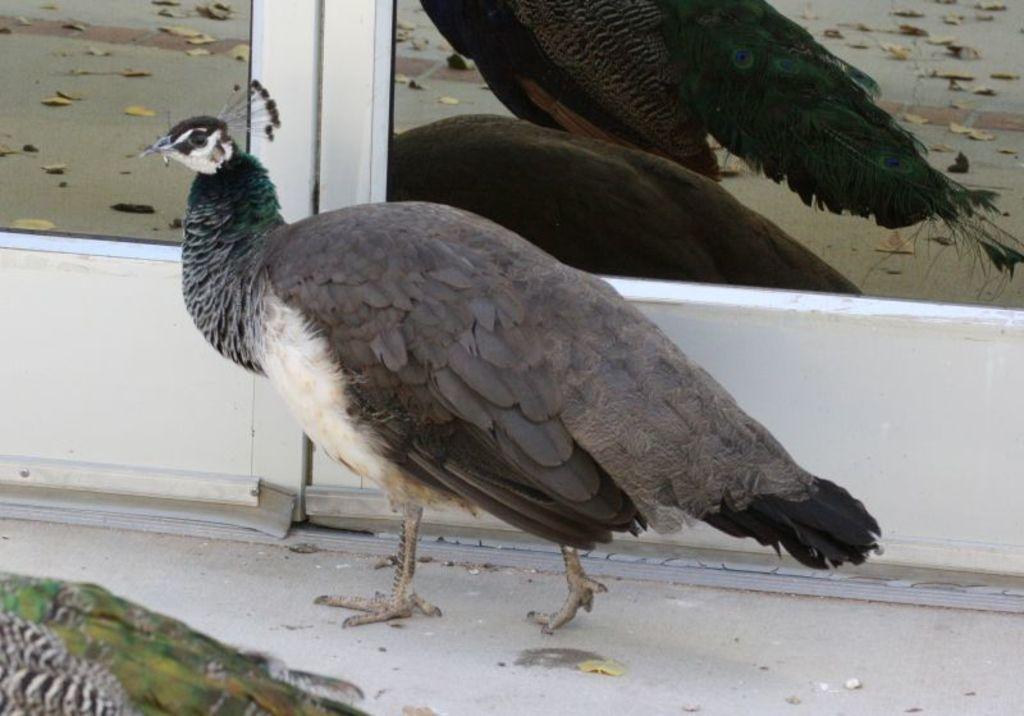Can you describe this image briefly? In this picture there is a peacock standing and there is another peacock beside it and there is a glass door in the background. 